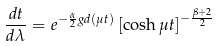<formula> <loc_0><loc_0><loc_500><loc_500>\frac { d t } { d \lambda } = e ^ { - \frac { \alpha } { 2 } g d ( \mu t ) } \left [ \cosh { \mu t } \right ] ^ { - \frac { \beta + 2 } { 2 } }</formula> 